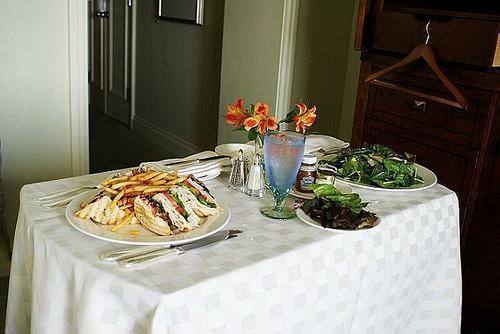How many glasses are there?
Give a very brief answer. 1. 